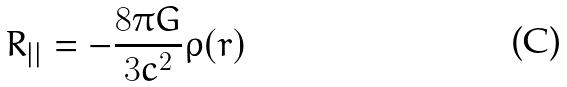<formula> <loc_0><loc_0><loc_500><loc_500>R _ { | | } = - \frac { 8 \pi G } { 3 c ^ { 2 } } \rho ( r )</formula> 